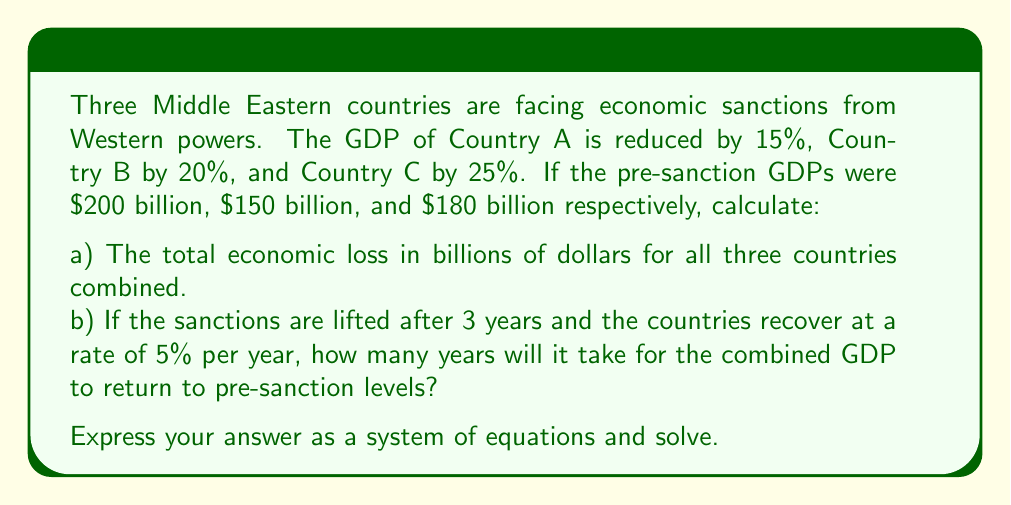Give your solution to this math problem. Let's approach this problem step-by-step:

a) To calculate the total economic loss:

1. Calculate the loss for each country:
   Country A: $200 \text{ billion} \times 15\% = $30 \text{ billion}$
   Country B: $150 \text{ billion} \times 20\% = $30 \text{ billion}$
   Country C: $180 \text{ billion} \times 25\% = $45 \text{ billion}$

2. Sum the losses:
   Total loss = $30 + $30 + $45 = $105 \text{ billion}$

b) To calculate the recovery time:

1. Calculate the post-sanction GDPs:
   Country A: $200 \text{ billion} - $30 \text{ billion} = $170 \text{ billion}$
   Country B: $150 \text{ billion} - $30 \text{ billion} = $120 \text{ billion}$
   Country C: $180 \text{ billion} - $45 \text{ billion} = $135 \text{ billion}$

2. Combined post-sanction GDP:
   $170 + $120 + $135 = $425 \text{ billion}$

3. Combined pre-sanction GDP:
   $200 + $150 + $180 = $530 \text{ billion}$

4. Let $x$ be the number of years after the 3-year sanction period. We can set up the equation:

   $$425 \times (1.05)^x = 530$$

5. Taking the natural log of both sides:

   $$\ln(425) + x\ln(1.05) = \ln(530)$$

6. Solving for $x$:

   $$x = \frac{\ln(530) - \ln(425)}{\ln(1.05)} \approx 4.44 \text{ years}$$

7. Total time = 3 years of sanctions + 4.44 years of recovery ≈ 7.44 years

Therefore, it will take approximately 7.44 years from the start of sanctions for the combined GDP to return to pre-sanction levels.
Answer: a) $105 billion
b) 7.44 years (rounded to two decimal places) 